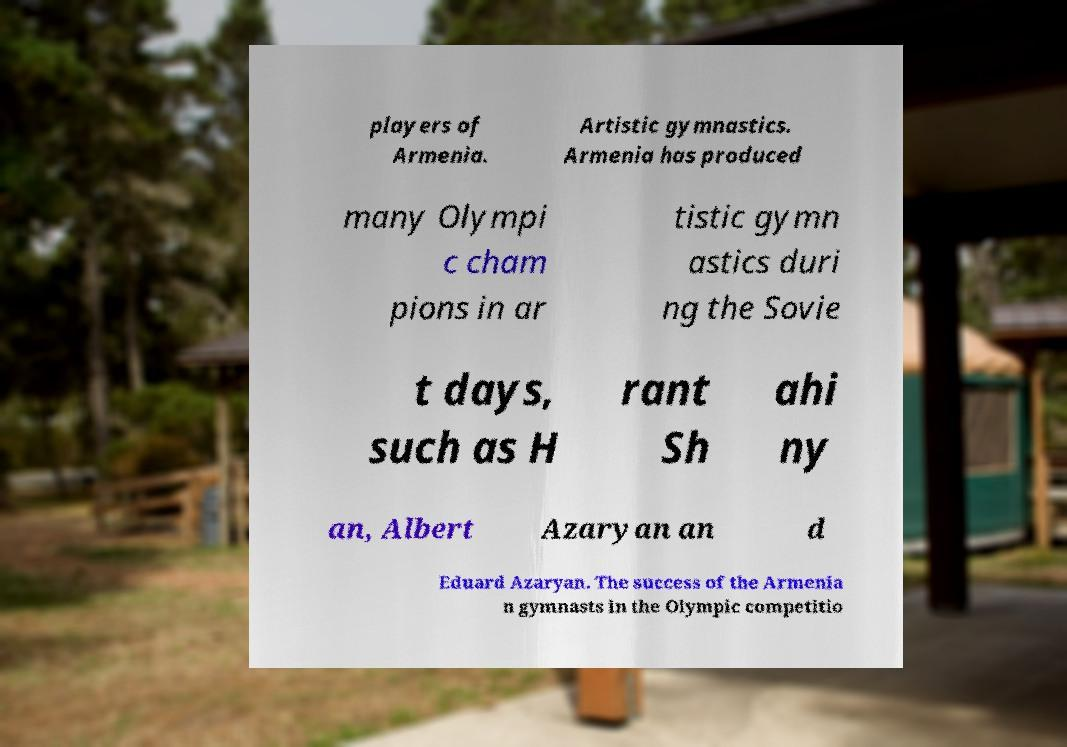What messages or text are displayed in this image? I need them in a readable, typed format. players of Armenia. Artistic gymnastics. Armenia has produced many Olympi c cham pions in ar tistic gymn astics duri ng the Sovie t days, such as H rant Sh ahi ny an, Albert Azaryan an d Eduard Azaryan. The success of the Armenia n gymnasts in the Olympic competitio 